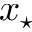<formula> <loc_0><loc_0><loc_500><loc_500>x _ { ^ { * } }</formula> 